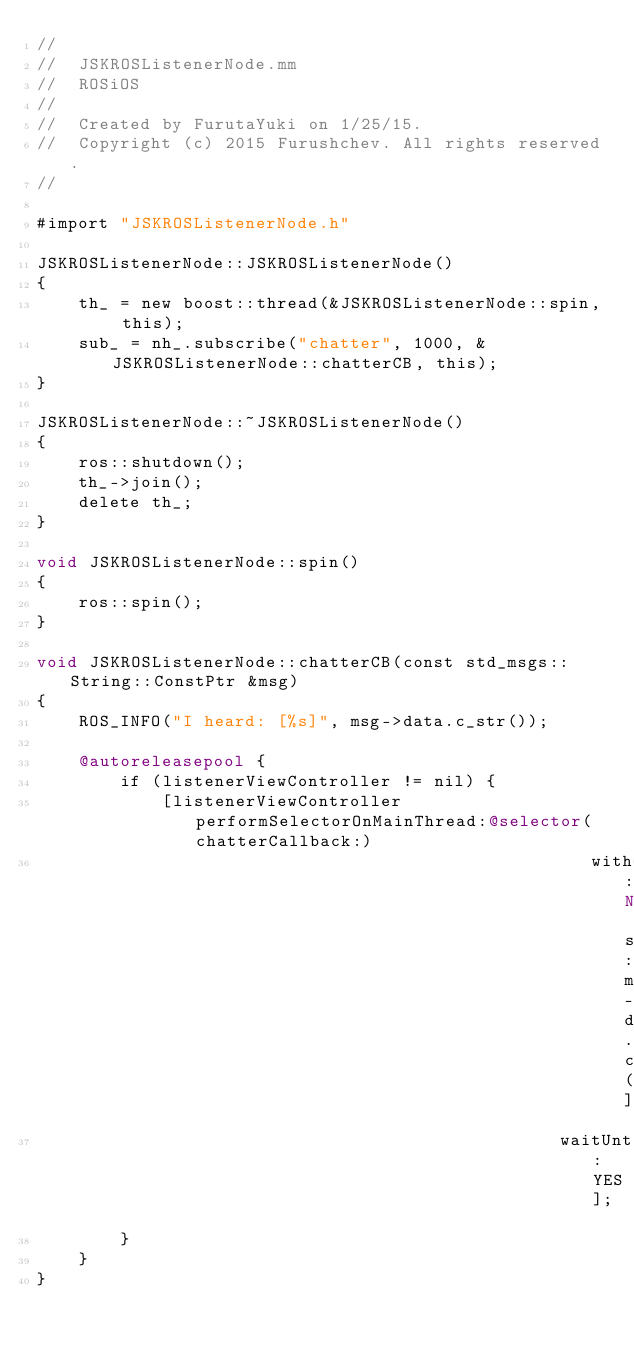Convert code to text. <code><loc_0><loc_0><loc_500><loc_500><_ObjectiveC_>//
//  JSKROSListenerNode.mm
//  ROSiOS
//
//  Created by FurutaYuki on 1/25/15.
//  Copyright (c) 2015 Furushchev. All rights reserved.
//

#import "JSKROSListenerNode.h"

JSKROSListenerNode::JSKROSListenerNode()
{
    th_ = new boost::thread(&JSKROSListenerNode::spin, this);
    sub_ = nh_.subscribe("chatter", 1000, &JSKROSListenerNode::chatterCB, this);
}

JSKROSListenerNode::~JSKROSListenerNode()
{
    ros::shutdown();
    th_->join();
    delete th_;
}

void JSKROSListenerNode::spin()
{
    ros::spin();
}

void JSKROSListenerNode::chatterCB(const std_msgs::String::ConstPtr &msg)
{
    ROS_INFO("I heard: [%s]", msg->data.c_str());
    
    @autoreleasepool {
        if (listenerViewController != nil) {
            [listenerViewController performSelectorOnMainThread:@selector(chatterCallback:)
                                                     withObject:[NSString stringWithUTF8String:msg->data.c_str()]
                                                  waitUntilDone:YES];
        }
    }
}</code> 